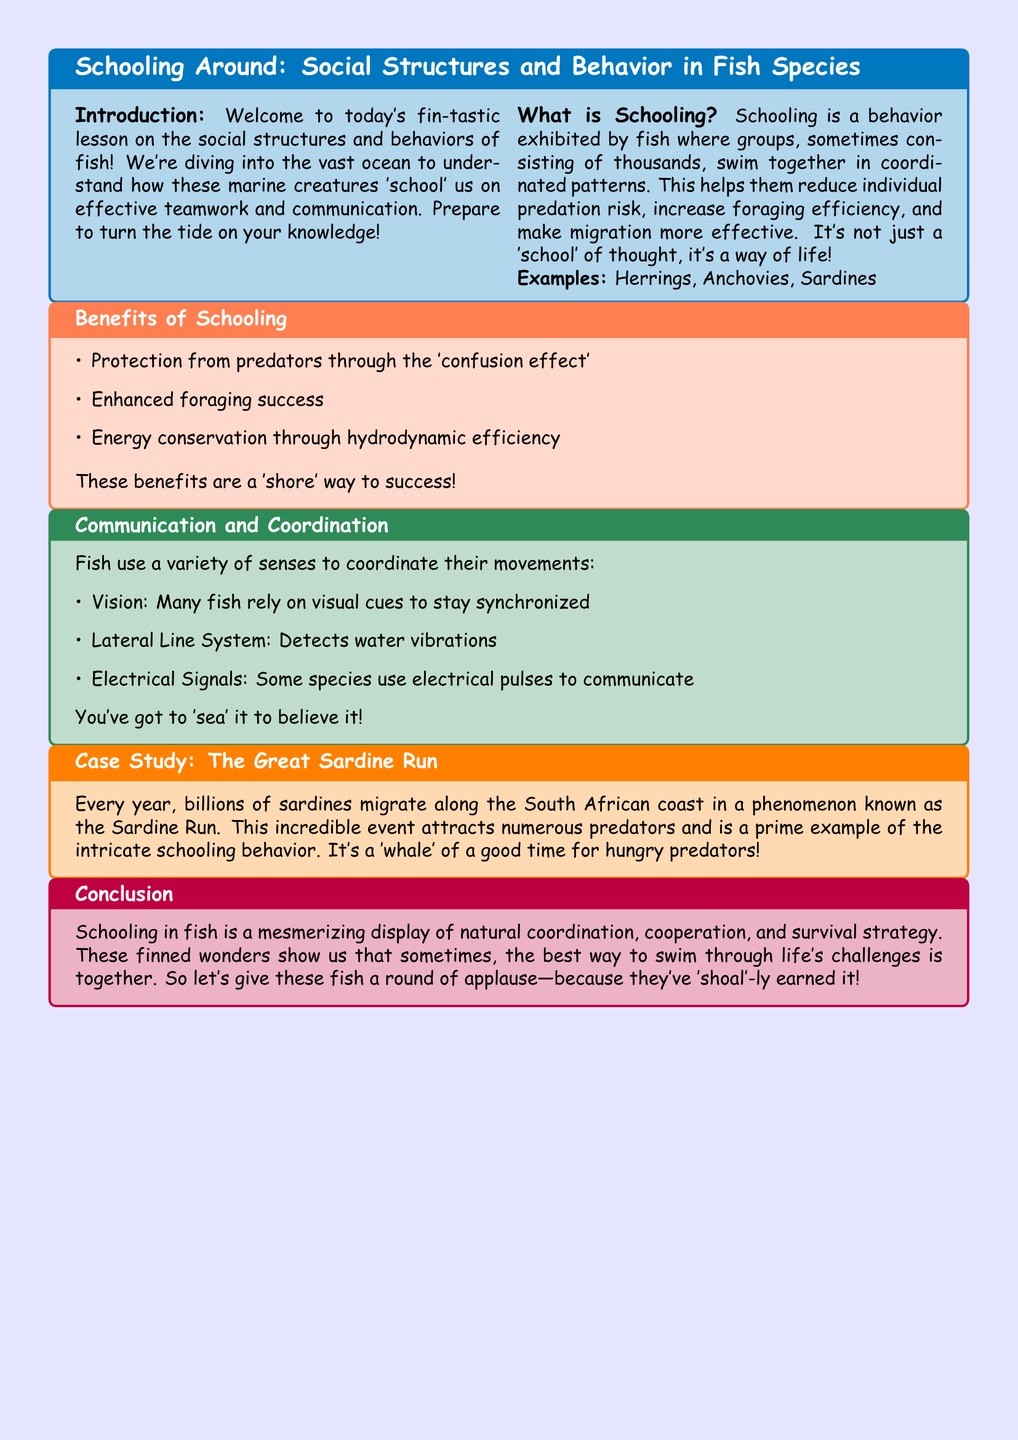What is the title of the lesson? The title of the lesson is provided at the beginning of the document in a tcolorbox.
Answer: Schooling Around: Social Structures and Behavior in Fish Species What behavior do fish exhibit in schooling? The document describes schooling as a behavior where fish swim together in coordinated patterns.
Answer: Coordinated patterns Name one of the fish species mentioned in the examples. The lesson plan provides examples of fish species that exhibit schooling behavior.
Answer: Herrings What is one benefit of schooling mentioned in the lesson? The document lists various benefits of schooling, focusing on aspects like predator protection and foraging.
Answer: Protection from predators What system do fish use to detect water vibrations? The lesson describes a specific sensory system that fish use for coordination.
Answer: Lateral Line System How many sardines are mentioned in the Sardine Run case study? The case study mentions the scale of the sardine migration each year.
Answer: Billions What is one method fish use for communication? The document discusses various methods fish use to coordinate their movements, including visual cues.
Answer: Vision What does the document recommend for tackling life's challenges? The conclusion suggests a metaphor for cooperation and collective effort in overcoming challenges.
Answer: Together What type of signals do some fish use for communication? Specific methods of communication are discussed, highlighting electrical communication.
Answer: Electrical Signals 